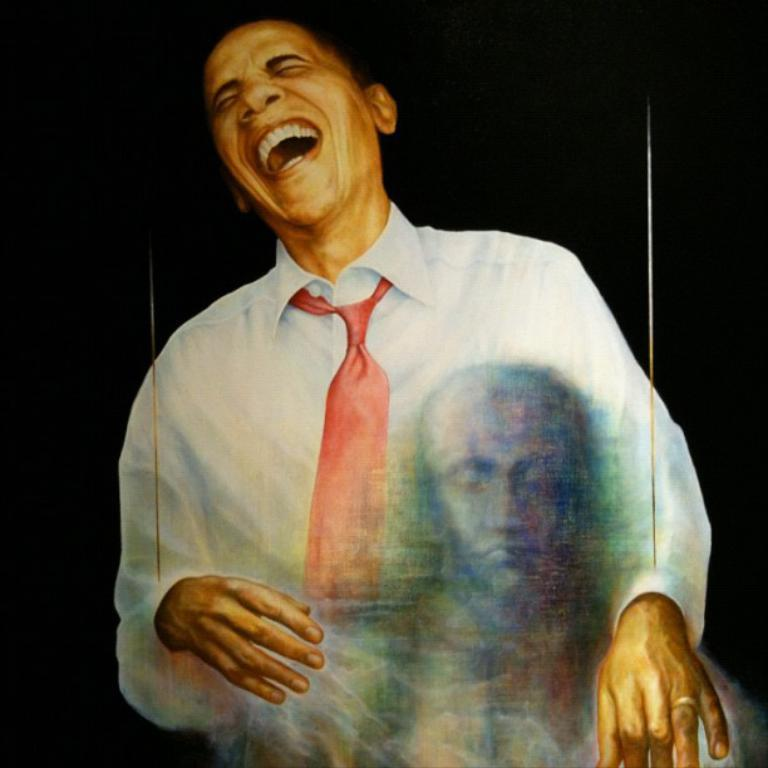What is depicted in the painting that features a person in the image? In the painting of a person laughing. Are there any other paintings visible in the image? Yes, there is another painting of a person in the image. What is the overall color scheme of the image? The background of the image is dark. How many knots can be seen in the image? There are no knots present in the image. What type of plate is being used by the person in the painting? There is no plate visible in the image, as it features paintings of people and not actual people using plates. 